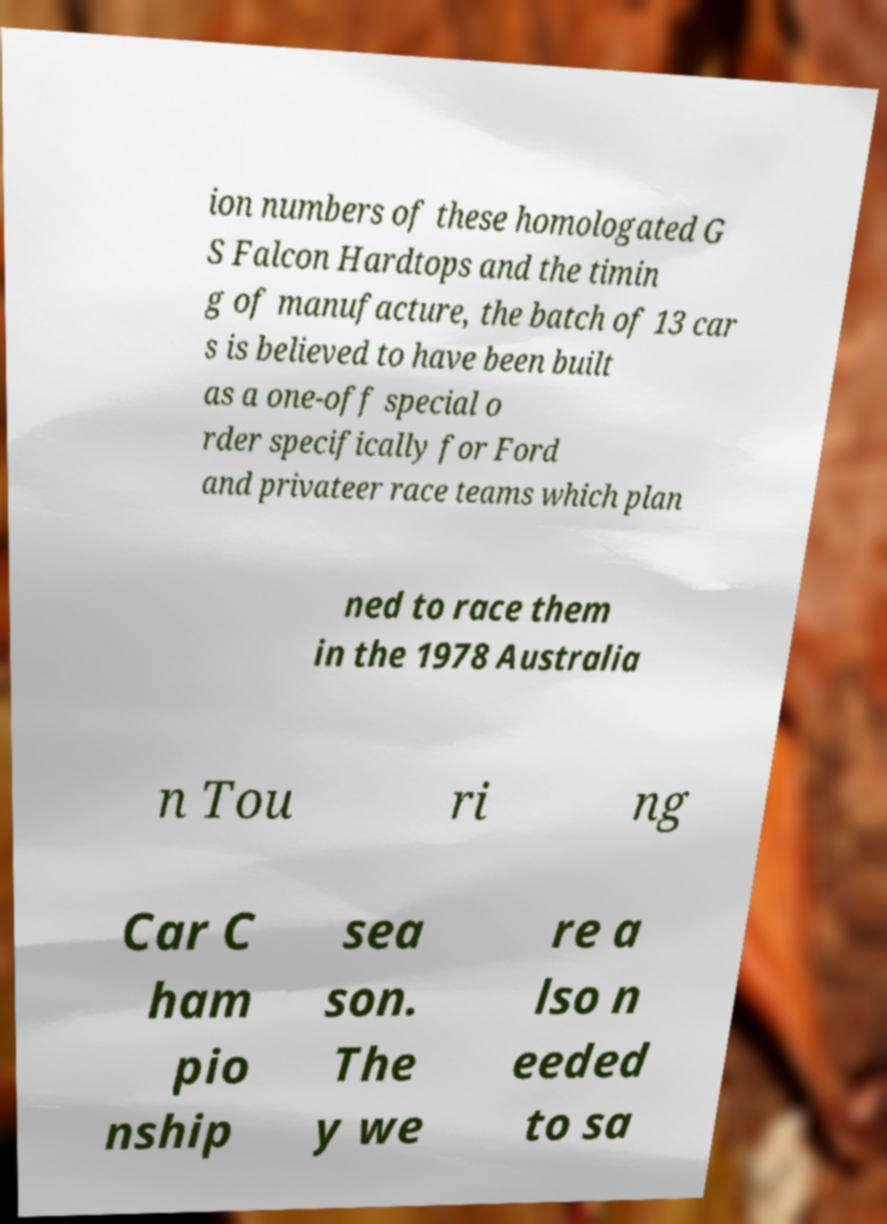Could you assist in decoding the text presented in this image and type it out clearly? ion numbers of these homologated G S Falcon Hardtops and the timin g of manufacture, the batch of 13 car s is believed to have been built as a one-off special o rder specifically for Ford and privateer race teams which plan ned to race them in the 1978 Australia n Tou ri ng Car C ham pio nship sea son. The y we re a lso n eeded to sa 